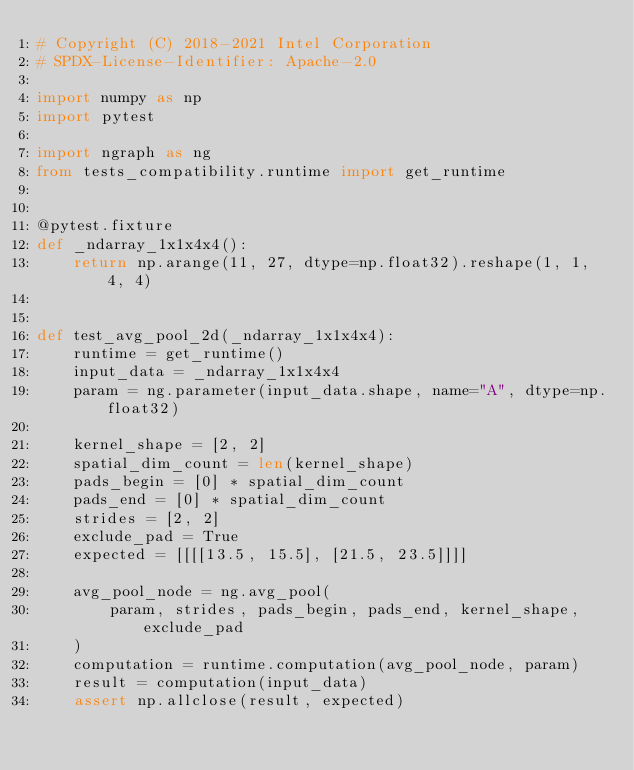<code> <loc_0><loc_0><loc_500><loc_500><_Python_># Copyright (C) 2018-2021 Intel Corporation
# SPDX-License-Identifier: Apache-2.0

import numpy as np
import pytest

import ngraph as ng
from tests_compatibility.runtime import get_runtime


@pytest.fixture
def _ndarray_1x1x4x4():
    return np.arange(11, 27, dtype=np.float32).reshape(1, 1, 4, 4)


def test_avg_pool_2d(_ndarray_1x1x4x4):
    runtime = get_runtime()
    input_data = _ndarray_1x1x4x4
    param = ng.parameter(input_data.shape, name="A", dtype=np.float32)

    kernel_shape = [2, 2]
    spatial_dim_count = len(kernel_shape)
    pads_begin = [0] * spatial_dim_count
    pads_end = [0] * spatial_dim_count
    strides = [2, 2]
    exclude_pad = True
    expected = [[[[13.5, 15.5], [21.5, 23.5]]]]

    avg_pool_node = ng.avg_pool(
        param, strides, pads_begin, pads_end, kernel_shape, exclude_pad
    )
    computation = runtime.computation(avg_pool_node, param)
    result = computation(input_data)
    assert np.allclose(result, expected)
</code> 